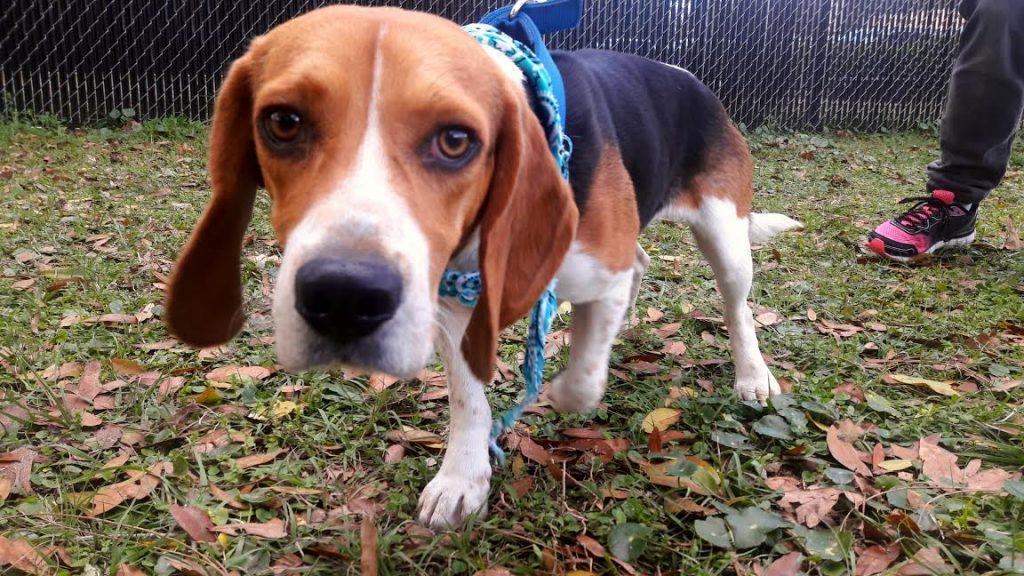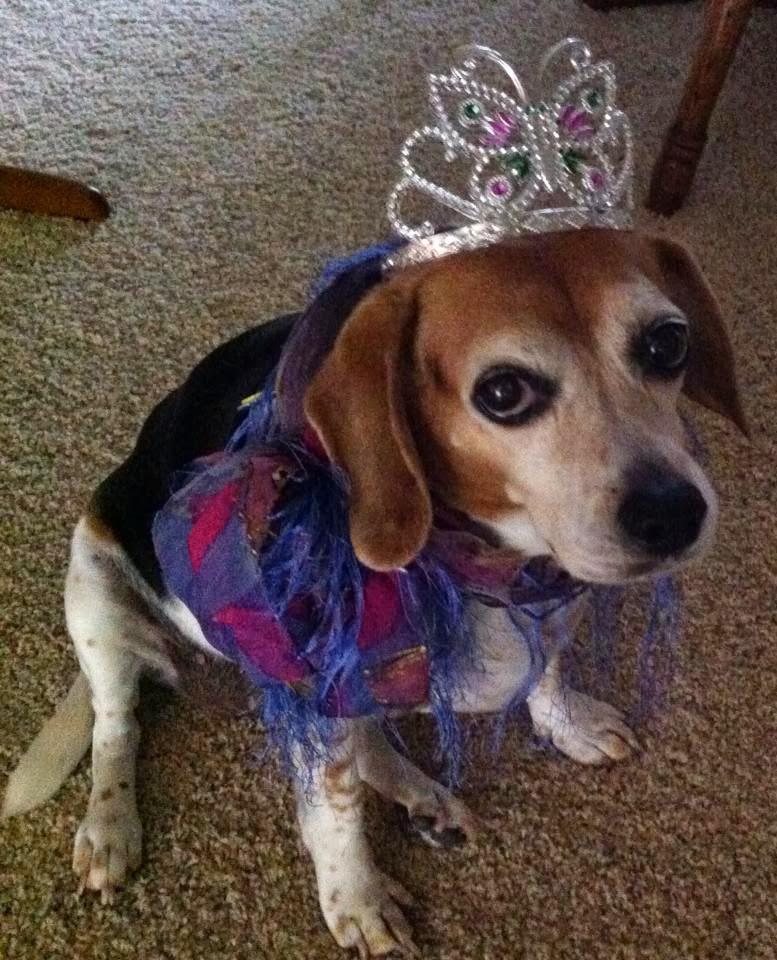The first image is the image on the left, the second image is the image on the right. Analyze the images presented: Is the assertion "A dog in one of the images is wearing something on top of its head." valid? Answer yes or no. Yes. The first image is the image on the left, the second image is the image on the right. Examine the images to the left and right. Is the description "One image contains one dog, which wears a blue collar, and the other image features a dog wearing a costume that includes a hat and something around its neck." accurate? Answer yes or no. Yes. 